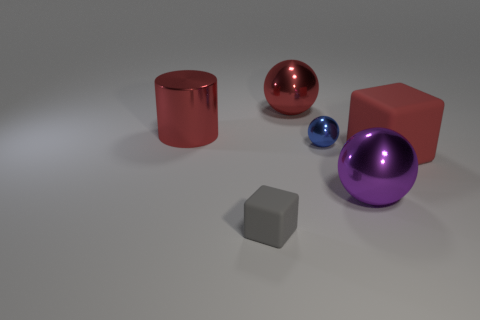Is the big rubber object the same color as the shiny cylinder?
Give a very brief answer. Yes. There is another red thing that is the same shape as the small rubber thing; what material is it?
Keep it short and to the point. Rubber. What number of purple balls are the same size as the red metal sphere?
Give a very brief answer. 1. Is there a shiny cylinder right of the sphere that is on the right side of the tiny blue metallic object?
Provide a succinct answer. No. How many red things are big objects or small rubber things?
Keep it short and to the point. 3. What is the color of the tiny block?
Offer a terse response. Gray. The purple sphere that is the same material as the blue sphere is what size?
Make the answer very short. Large. How many small blue things are the same shape as the gray rubber object?
Your answer should be very brief. 0. What is the size of the red metallic thing that is to the right of the big thing that is to the left of the small gray rubber cube?
Provide a succinct answer. Large. There is a red cylinder that is the same size as the purple metallic sphere; what is its material?
Your response must be concise. Metal. 